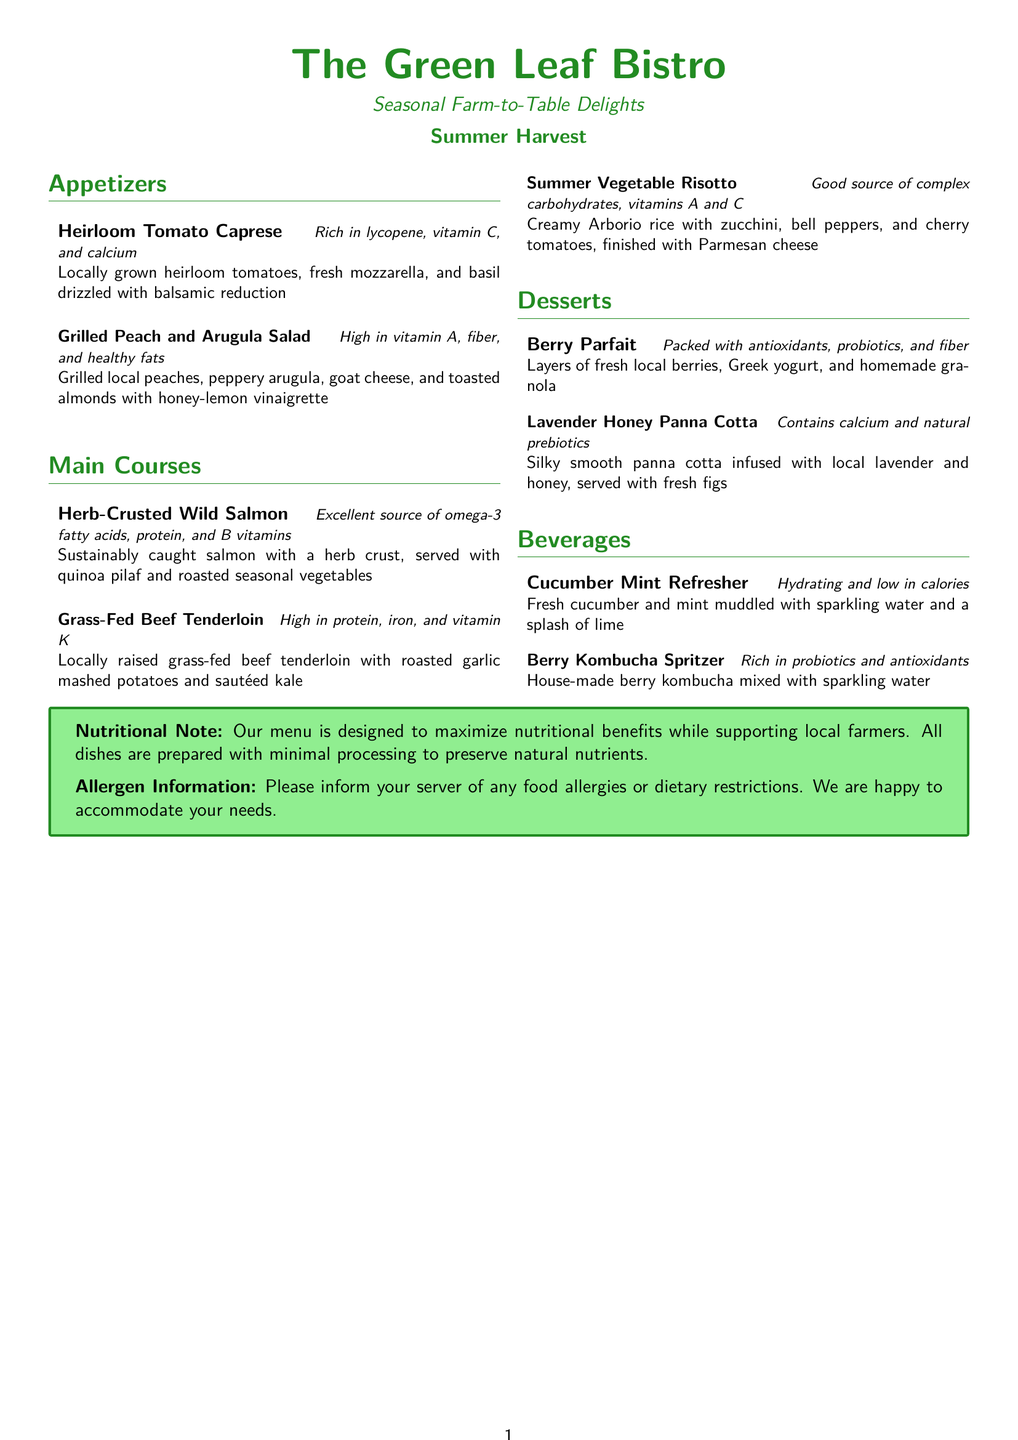What is the name of the bistro? The name is presented at the beginning of the menu document.
Answer: The Green Leaf Bistro What type of menu is being offered? The menu specifies the type of dining experience being provided, emphasizing seasonal ingredients.
Answer: Seasonal Farm-to-Table Delights Which appetizer contains arugula? The appetizer list includes specific items and their components, making it possible to identify the one with arugula.
Answer: Grilled Peach and Arugula Salad What is the primary protein source in the Herb-Crusted Wild Salmon dish? The main course section highlights the main ingredients, allowing identification of the protein source.
Answer: Salmon What is the main vegetable in the Summer Vegetable Risotto? The menu item description provides insight into the main ingredients, particularly the key vegetable.
Answer: Zucchini How many desserts are listed on the menu? The dessert section provides a specific count of the items offered.
Answer: Two What is a key health benefit of the Berry Parfait? Each dessert includes a brief description of its nutritional benefits, which aids in answering this question.
Answer: Antioxidants Which beverage is described as hydrating and low in calories? The beverage descriptions include nutritional qualities that can help identify the right drink.
Answer: Cucumber Mint Refresher What allergen information is provided on the menu? A separate section at the bottom outlines the allergen protocol, allowing one to answer this question directly.
Answer: Inform your server of any food allergies or dietary restrictions 